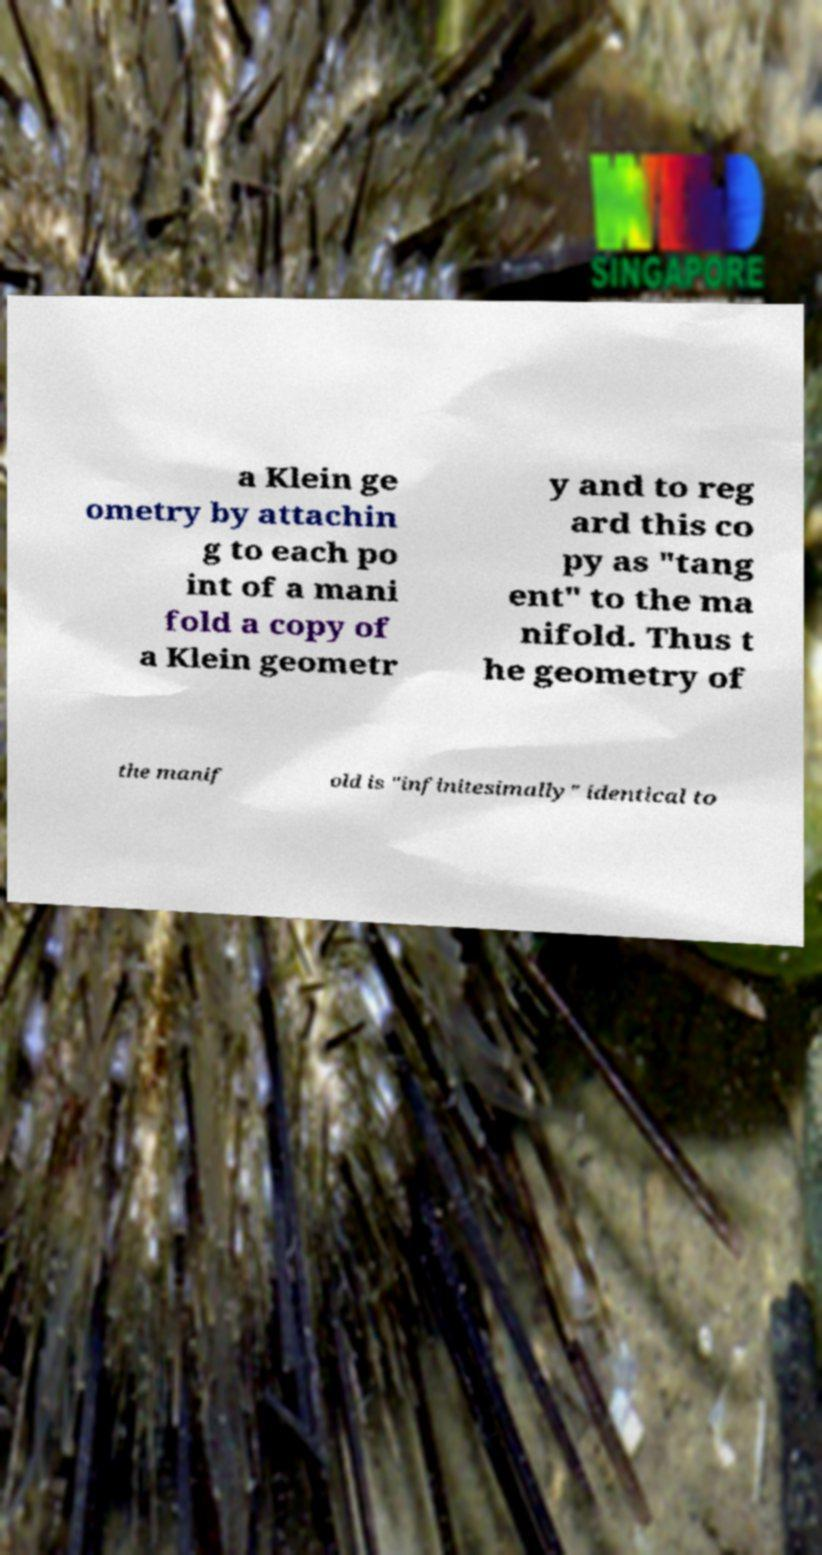Please read and relay the text visible in this image. What does it say? a Klein ge ometry by attachin g to each po int of a mani fold a copy of a Klein geometr y and to reg ard this co py as "tang ent" to the ma nifold. Thus t he geometry of the manif old is "infinitesimally" identical to 